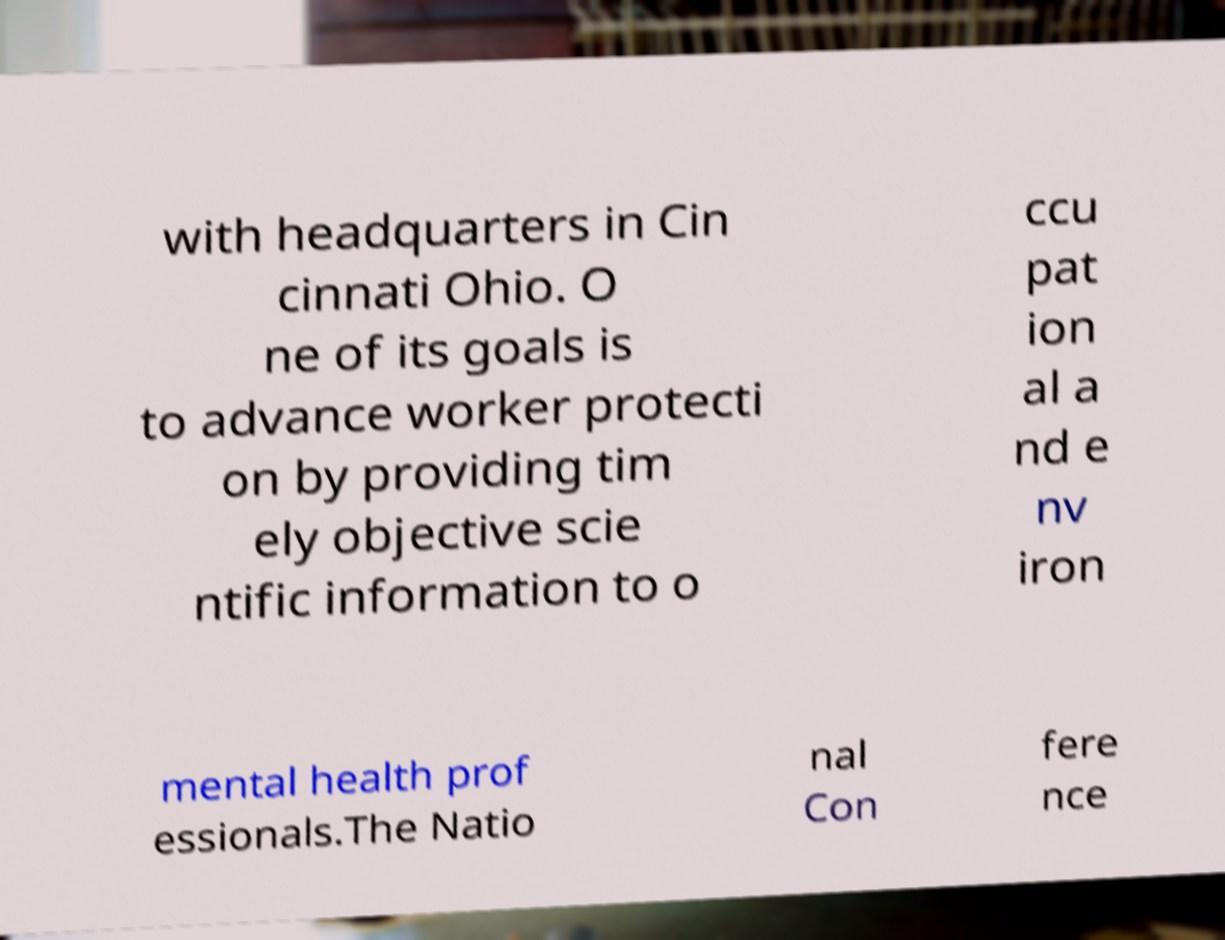Can you read and provide the text displayed in the image?This photo seems to have some interesting text. Can you extract and type it out for me? with headquarters in Cin cinnati Ohio. O ne of its goals is to advance worker protecti on by providing tim ely objective scie ntific information to o ccu pat ion al a nd e nv iron mental health prof essionals.The Natio nal Con fere nce 